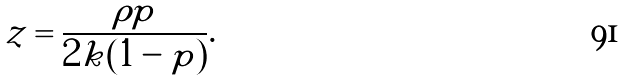Convert formula to latex. <formula><loc_0><loc_0><loc_500><loc_500>z = \frac { \rho p } { 2 k ( 1 - p ) } .</formula> 